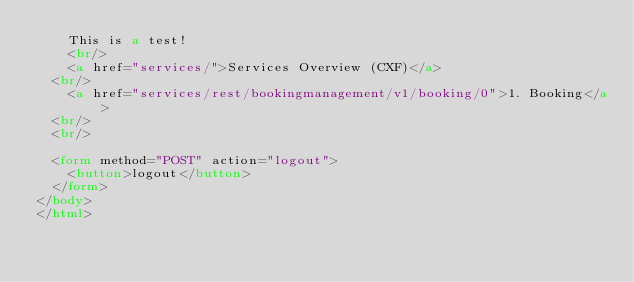<code> <loc_0><loc_0><loc_500><loc_500><_HTML_>	This is a test!
	<br/>
	<a href="services/">Services Overview (CXF)</a>
  <br/>
	<a href="services/rest/bookingmanagement/v1/booking/0">1. Booking</a>
  <br/>
  <br/>

  <form method="POST" action="logout">
    <button>logout</button>
  </form>
</body>
</html></code> 